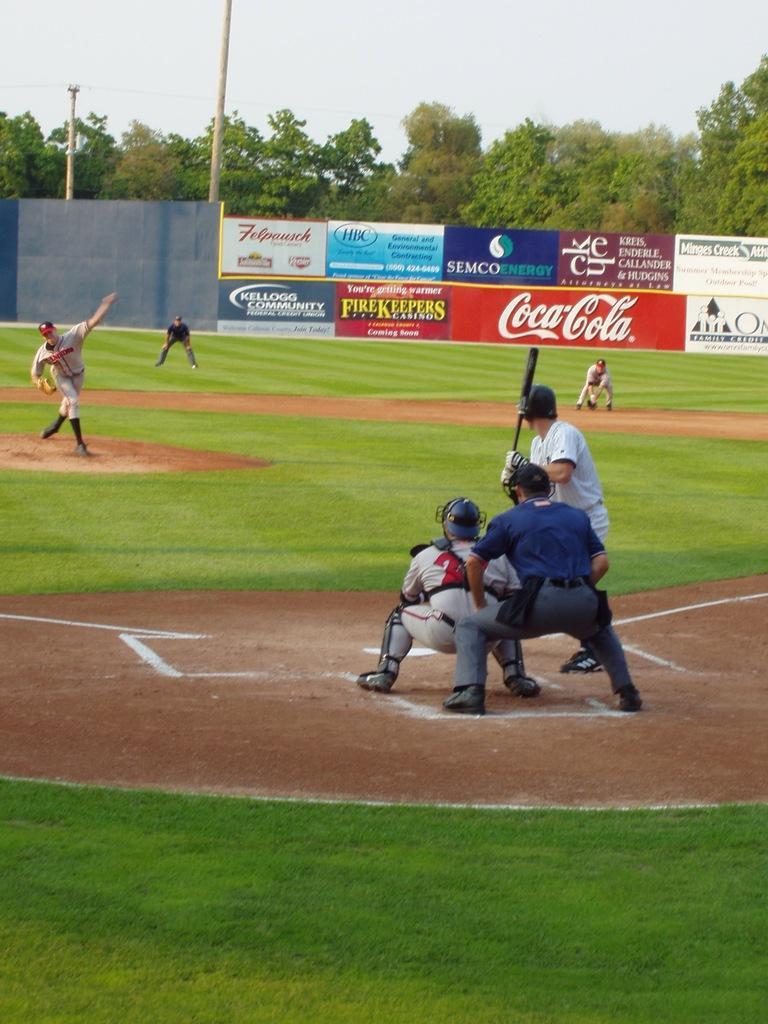Can you describe this image briefly? In this image in the center there are some persons one person is holding a bat and it seems that they are playing cricket. At the bottom there is ground, and in the background there are some trees, boards and poles. 